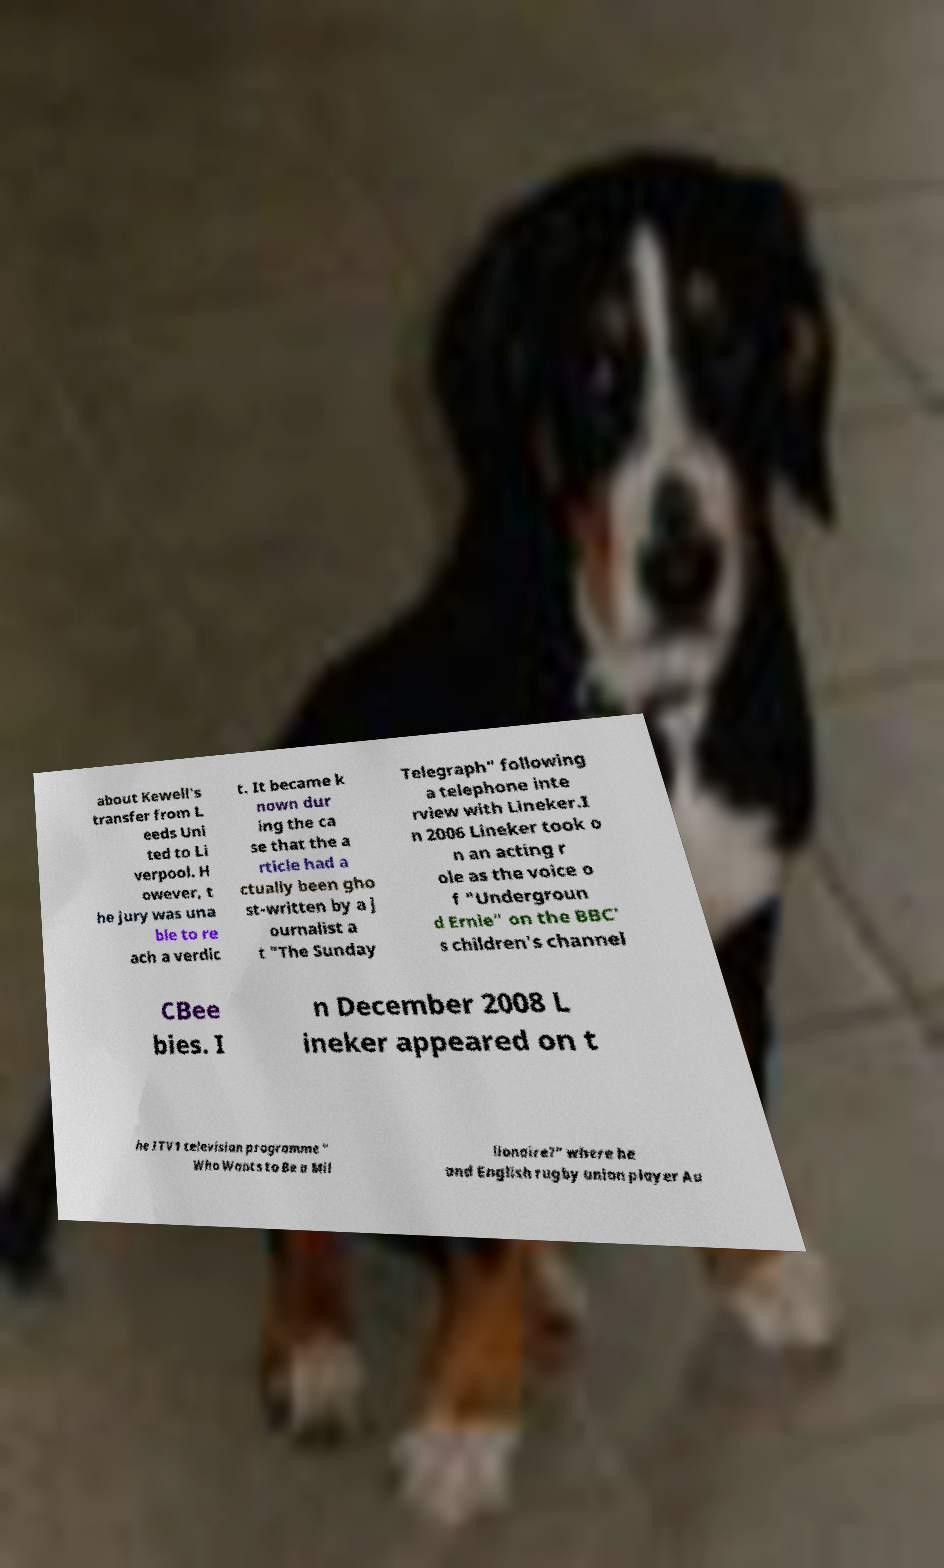For documentation purposes, I need the text within this image transcribed. Could you provide that? about Kewell's transfer from L eeds Uni ted to Li verpool. H owever, t he jury was una ble to re ach a verdic t. It became k nown dur ing the ca se that the a rticle had a ctually been gho st-written by a j ournalist a t "The Sunday Telegraph" following a telephone inte rview with Lineker.I n 2006 Lineker took o n an acting r ole as the voice o f "Undergroun d Ernie" on the BBC' s children's channel CBee bies. I n December 2008 L ineker appeared on t he ITV1 television programme " Who Wants to Be a Mil lionaire?" where he and English rugby union player Au 